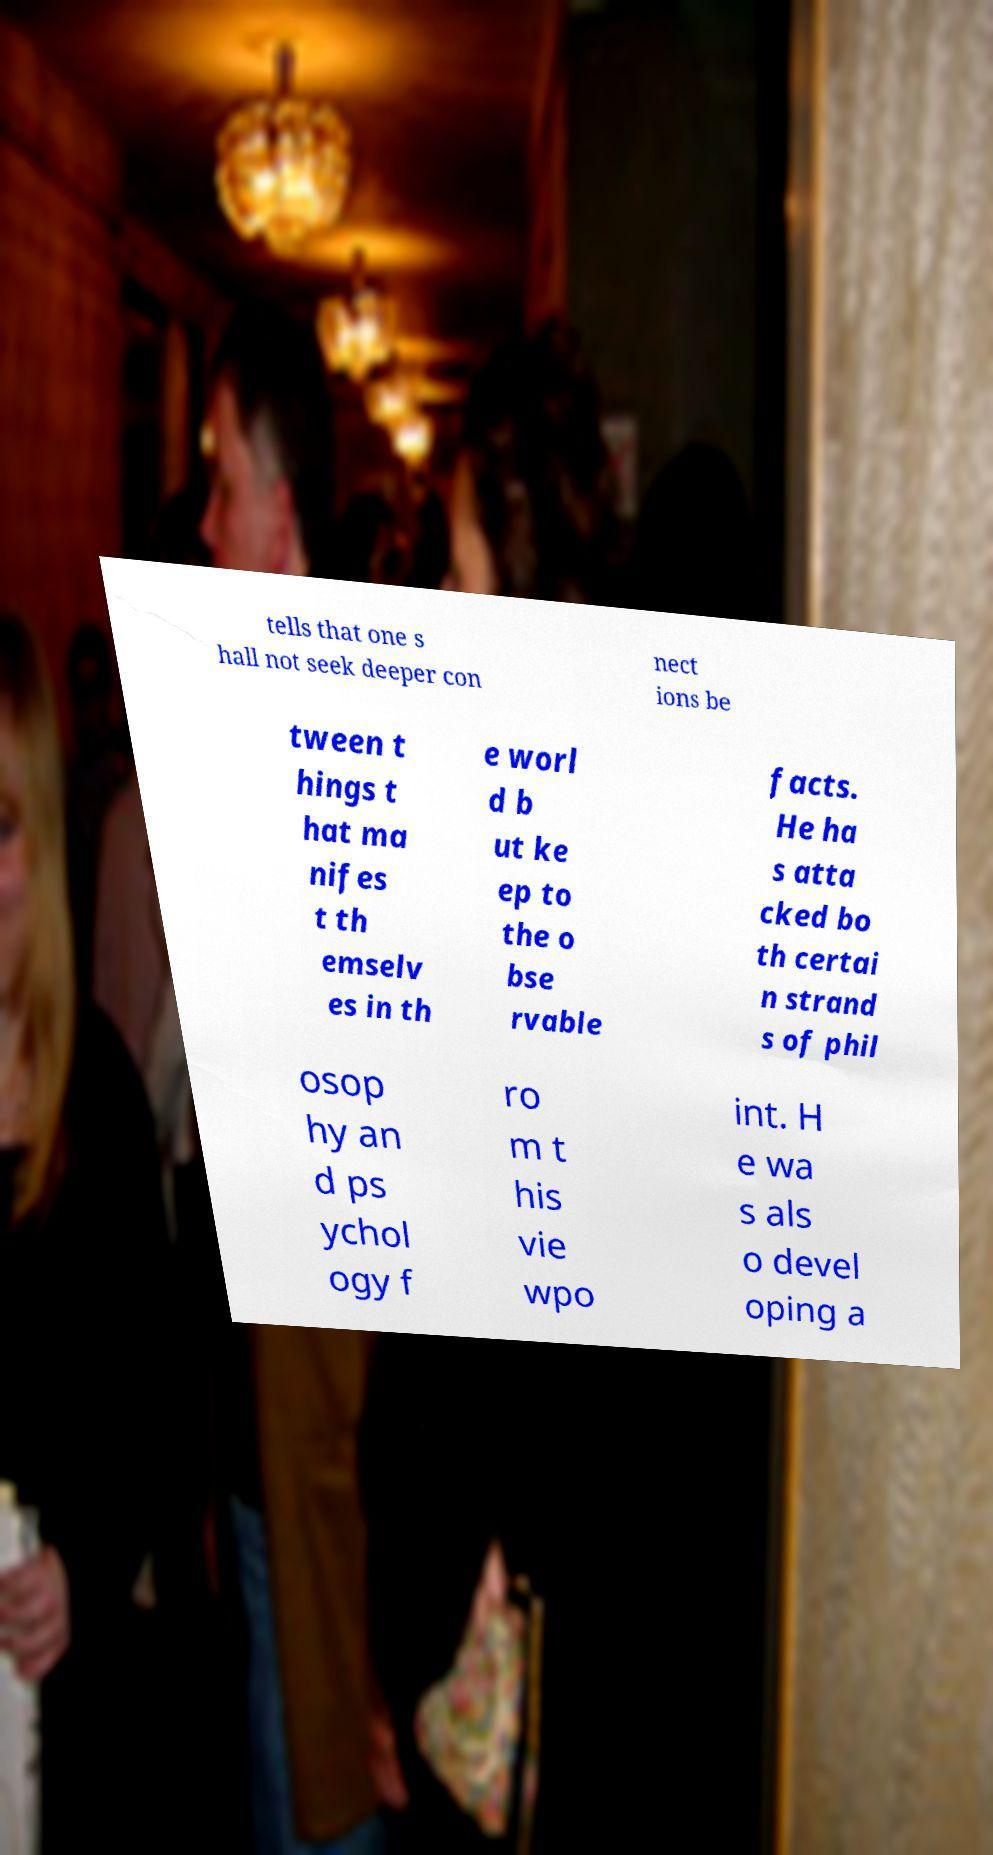Can you accurately transcribe the text from the provided image for me? tells that one s hall not seek deeper con nect ions be tween t hings t hat ma nifes t th emselv es in th e worl d b ut ke ep to the o bse rvable facts. He ha s atta cked bo th certai n strand s of phil osop hy an d ps ychol ogy f ro m t his vie wpo int. H e wa s als o devel oping a 